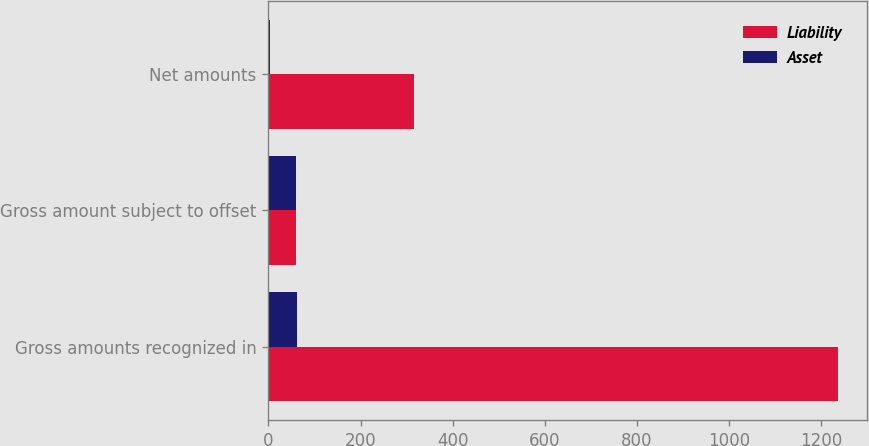<chart> <loc_0><loc_0><loc_500><loc_500><stacked_bar_chart><ecel><fcel>Gross amounts recognized in<fcel>Gross amount subject to offset<fcel>Net amounts<nl><fcel>Liability<fcel>1237<fcel>59<fcel>316<nl><fcel>Asset<fcel>63<fcel>59<fcel>4<nl></chart> 